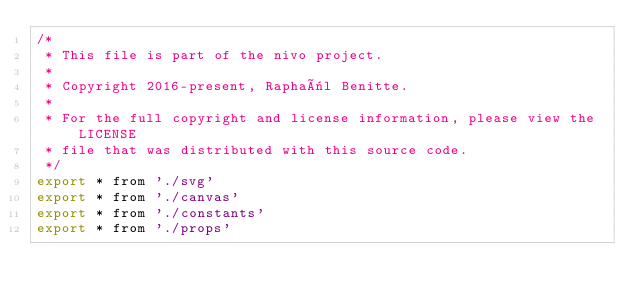<code> <loc_0><loc_0><loc_500><loc_500><_JavaScript_>/*
 * This file is part of the nivo project.
 *
 * Copyright 2016-present, Raphaël Benitte.
 *
 * For the full copyright and license information, please view the LICENSE
 * file that was distributed with this source code.
 */
export * from './svg'
export * from './canvas'
export * from './constants'
export * from './props'
</code> 